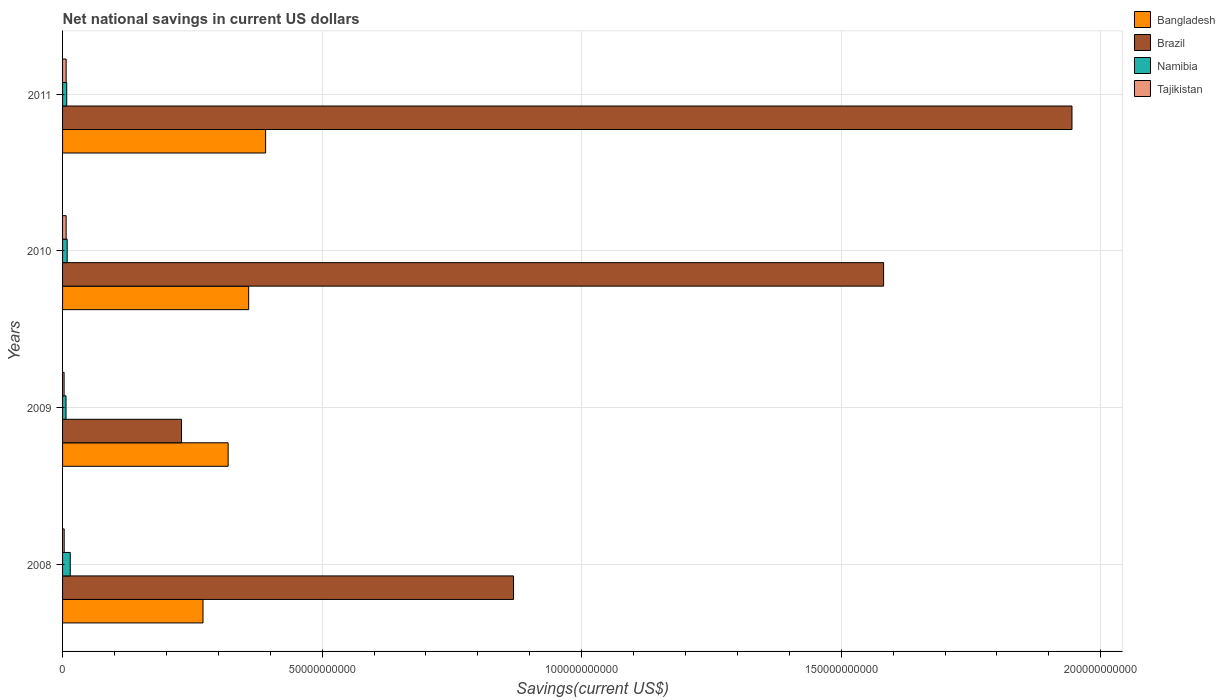How many different coloured bars are there?
Provide a short and direct response. 4. How many groups of bars are there?
Keep it short and to the point. 4. Are the number of bars per tick equal to the number of legend labels?
Give a very brief answer. Yes. How many bars are there on the 2nd tick from the bottom?
Give a very brief answer. 4. What is the label of the 2nd group of bars from the top?
Your response must be concise. 2010. In how many cases, is the number of bars for a given year not equal to the number of legend labels?
Offer a terse response. 0. What is the net national savings in Brazil in 2008?
Make the answer very short. 8.69e+1. Across all years, what is the maximum net national savings in Bangladesh?
Keep it short and to the point. 3.91e+1. Across all years, what is the minimum net national savings in Bangladesh?
Offer a very short reply. 2.71e+1. In which year was the net national savings in Bangladesh minimum?
Make the answer very short. 2008. What is the total net national savings in Tajikistan in the graph?
Provide a succinct answer. 1.98e+09. What is the difference between the net national savings in Tajikistan in 2010 and that in 2011?
Offer a terse response. -2.02e+06. What is the difference between the net national savings in Namibia in 2011 and the net national savings in Brazil in 2008?
Provide a short and direct response. -8.61e+1. What is the average net national savings in Brazil per year?
Provide a short and direct response. 1.16e+11. In the year 2011, what is the difference between the net national savings in Bangladesh and net national savings in Brazil?
Your answer should be very brief. -1.55e+11. What is the ratio of the net national savings in Namibia in 2008 to that in 2011?
Provide a short and direct response. 1.85. Is the difference between the net national savings in Bangladesh in 2009 and 2011 greater than the difference between the net national savings in Brazil in 2009 and 2011?
Make the answer very short. Yes. What is the difference between the highest and the second highest net national savings in Brazil?
Ensure brevity in your answer.  3.63e+1. What is the difference between the highest and the lowest net national savings in Namibia?
Provide a succinct answer. 8.15e+08. In how many years, is the net national savings in Tajikistan greater than the average net national savings in Tajikistan taken over all years?
Your answer should be very brief. 2. Is the sum of the net national savings in Tajikistan in 2008 and 2010 greater than the maximum net national savings in Namibia across all years?
Make the answer very short. No. Is it the case that in every year, the sum of the net national savings in Tajikistan and net national savings in Bangladesh is greater than the sum of net national savings in Brazil and net national savings in Namibia?
Offer a terse response. No. How many years are there in the graph?
Your answer should be compact. 4. What is the difference between two consecutive major ticks on the X-axis?
Your answer should be very brief. 5.00e+1. Are the values on the major ticks of X-axis written in scientific E-notation?
Your response must be concise. No. Does the graph contain any zero values?
Your answer should be compact. No. Where does the legend appear in the graph?
Ensure brevity in your answer.  Top right. What is the title of the graph?
Offer a terse response. Net national savings in current US dollars. What is the label or title of the X-axis?
Offer a terse response. Savings(current US$). What is the Savings(current US$) of Bangladesh in 2008?
Offer a terse response. 2.71e+1. What is the Savings(current US$) in Brazil in 2008?
Provide a succinct answer. 8.69e+1. What is the Savings(current US$) in Namibia in 2008?
Your answer should be compact. 1.48e+09. What is the Savings(current US$) of Tajikistan in 2008?
Keep it short and to the point. 3.11e+08. What is the Savings(current US$) of Bangladesh in 2009?
Your answer should be compact. 3.19e+1. What is the Savings(current US$) in Brazil in 2009?
Make the answer very short. 2.29e+1. What is the Savings(current US$) of Namibia in 2009?
Give a very brief answer. 6.64e+08. What is the Savings(current US$) of Tajikistan in 2009?
Your answer should be very brief. 2.95e+08. What is the Savings(current US$) in Bangladesh in 2010?
Give a very brief answer. 3.59e+1. What is the Savings(current US$) in Brazil in 2010?
Offer a terse response. 1.58e+11. What is the Savings(current US$) of Namibia in 2010?
Your answer should be compact. 8.89e+08. What is the Savings(current US$) in Tajikistan in 2010?
Provide a succinct answer. 6.86e+08. What is the Savings(current US$) of Bangladesh in 2011?
Provide a short and direct response. 3.91e+1. What is the Savings(current US$) of Brazil in 2011?
Offer a terse response. 1.94e+11. What is the Savings(current US$) of Namibia in 2011?
Make the answer very short. 8.00e+08. What is the Savings(current US$) of Tajikistan in 2011?
Give a very brief answer. 6.88e+08. Across all years, what is the maximum Savings(current US$) in Bangladesh?
Ensure brevity in your answer.  3.91e+1. Across all years, what is the maximum Savings(current US$) of Brazil?
Keep it short and to the point. 1.94e+11. Across all years, what is the maximum Savings(current US$) of Namibia?
Your answer should be very brief. 1.48e+09. Across all years, what is the maximum Savings(current US$) in Tajikistan?
Give a very brief answer. 6.88e+08. Across all years, what is the minimum Savings(current US$) in Bangladesh?
Provide a short and direct response. 2.71e+1. Across all years, what is the minimum Savings(current US$) of Brazil?
Keep it short and to the point. 2.29e+1. Across all years, what is the minimum Savings(current US$) of Namibia?
Give a very brief answer. 6.64e+08. Across all years, what is the minimum Savings(current US$) of Tajikistan?
Ensure brevity in your answer.  2.95e+08. What is the total Savings(current US$) of Bangladesh in the graph?
Give a very brief answer. 1.34e+11. What is the total Savings(current US$) of Brazil in the graph?
Make the answer very short. 4.62e+11. What is the total Savings(current US$) in Namibia in the graph?
Keep it short and to the point. 3.83e+09. What is the total Savings(current US$) of Tajikistan in the graph?
Your response must be concise. 1.98e+09. What is the difference between the Savings(current US$) in Bangladesh in 2008 and that in 2009?
Your answer should be very brief. -4.84e+09. What is the difference between the Savings(current US$) of Brazil in 2008 and that in 2009?
Provide a short and direct response. 6.40e+1. What is the difference between the Savings(current US$) of Namibia in 2008 and that in 2009?
Offer a very short reply. 8.15e+08. What is the difference between the Savings(current US$) of Tajikistan in 2008 and that in 2009?
Give a very brief answer. 1.60e+07. What is the difference between the Savings(current US$) in Bangladesh in 2008 and that in 2010?
Give a very brief answer. -8.80e+09. What is the difference between the Savings(current US$) in Brazil in 2008 and that in 2010?
Keep it short and to the point. -7.13e+1. What is the difference between the Savings(current US$) of Namibia in 2008 and that in 2010?
Offer a terse response. 5.90e+08. What is the difference between the Savings(current US$) of Tajikistan in 2008 and that in 2010?
Offer a terse response. -3.75e+08. What is the difference between the Savings(current US$) of Bangladesh in 2008 and that in 2011?
Your response must be concise. -1.21e+1. What is the difference between the Savings(current US$) of Brazil in 2008 and that in 2011?
Offer a very short reply. -1.08e+11. What is the difference between the Savings(current US$) of Namibia in 2008 and that in 2011?
Provide a succinct answer. 6.80e+08. What is the difference between the Savings(current US$) in Tajikistan in 2008 and that in 2011?
Offer a terse response. -3.77e+08. What is the difference between the Savings(current US$) of Bangladesh in 2009 and that in 2010?
Provide a short and direct response. -3.95e+09. What is the difference between the Savings(current US$) of Brazil in 2009 and that in 2010?
Ensure brevity in your answer.  -1.35e+11. What is the difference between the Savings(current US$) of Namibia in 2009 and that in 2010?
Your response must be concise. -2.25e+08. What is the difference between the Savings(current US$) of Tajikistan in 2009 and that in 2010?
Give a very brief answer. -3.91e+08. What is the difference between the Savings(current US$) of Bangladesh in 2009 and that in 2011?
Provide a succinct answer. -7.22e+09. What is the difference between the Savings(current US$) in Brazil in 2009 and that in 2011?
Make the answer very short. -1.72e+11. What is the difference between the Savings(current US$) in Namibia in 2009 and that in 2011?
Your answer should be very brief. -1.36e+08. What is the difference between the Savings(current US$) in Tajikistan in 2009 and that in 2011?
Your answer should be compact. -3.93e+08. What is the difference between the Savings(current US$) of Bangladesh in 2010 and that in 2011?
Your answer should be very brief. -3.26e+09. What is the difference between the Savings(current US$) of Brazil in 2010 and that in 2011?
Ensure brevity in your answer.  -3.63e+1. What is the difference between the Savings(current US$) in Namibia in 2010 and that in 2011?
Your answer should be very brief. 8.98e+07. What is the difference between the Savings(current US$) in Tajikistan in 2010 and that in 2011?
Ensure brevity in your answer.  -2.02e+06. What is the difference between the Savings(current US$) in Bangladesh in 2008 and the Savings(current US$) in Brazil in 2009?
Provide a short and direct response. 4.14e+09. What is the difference between the Savings(current US$) in Bangladesh in 2008 and the Savings(current US$) in Namibia in 2009?
Make the answer very short. 2.64e+1. What is the difference between the Savings(current US$) in Bangladesh in 2008 and the Savings(current US$) in Tajikistan in 2009?
Ensure brevity in your answer.  2.68e+1. What is the difference between the Savings(current US$) of Brazil in 2008 and the Savings(current US$) of Namibia in 2009?
Offer a terse response. 8.62e+1. What is the difference between the Savings(current US$) in Brazil in 2008 and the Savings(current US$) in Tajikistan in 2009?
Make the answer very short. 8.66e+1. What is the difference between the Savings(current US$) in Namibia in 2008 and the Savings(current US$) in Tajikistan in 2009?
Make the answer very short. 1.18e+09. What is the difference between the Savings(current US$) of Bangladesh in 2008 and the Savings(current US$) of Brazil in 2010?
Make the answer very short. -1.31e+11. What is the difference between the Savings(current US$) in Bangladesh in 2008 and the Savings(current US$) in Namibia in 2010?
Ensure brevity in your answer.  2.62e+1. What is the difference between the Savings(current US$) of Bangladesh in 2008 and the Savings(current US$) of Tajikistan in 2010?
Your response must be concise. 2.64e+1. What is the difference between the Savings(current US$) of Brazil in 2008 and the Savings(current US$) of Namibia in 2010?
Offer a very short reply. 8.60e+1. What is the difference between the Savings(current US$) in Brazil in 2008 and the Savings(current US$) in Tajikistan in 2010?
Provide a succinct answer. 8.62e+1. What is the difference between the Savings(current US$) of Namibia in 2008 and the Savings(current US$) of Tajikistan in 2010?
Make the answer very short. 7.93e+08. What is the difference between the Savings(current US$) in Bangladesh in 2008 and the Savings(current US$) in Brazil in 2011?
Your answer should be compact. -1.67e+11. What is the difference between the Savings(current US$) in Bangladesh in 2008 and the Savings(current US$) in Namibia in 2011?
Make the answer very short. 2.63e+1. What is the difference between the Savings(current US$) in Bangladesh in 2008 and the Savings(current US$) in Tajikistan in 2011?
Ensure brevity in your answer.  2.64e+1. What is the difference between the Savings(current US$) in Brazil in 2008 and the Savings(current US$) in Namibia in 2011?
Keep it short and to the point. 8.61e+1. What is the difference between the Savings(current US$) in Brazil in 2008 and the Savings(current US$) in Tajikistan in 2011?
Provide a short and direct response. 8.62e+1. What is the difference between the Savings(current US$) of Namibia in 2008 and the Savings(current US$) of Tajikistan in 2011?
Your response must be concise. 7.91e+08. What is the difference between the Savings(current US$) of Bangladesh in 2009 and the Savings(current US$) of Brazil in 2010?
Your answer should be very brief. -1.26e+11. What is the difference between the Savings(current US$) of Bangladesh in 2009 and the Savings(current US$) of Namibia in 2010?
Give a very brief answer. 3.10e+1. What is the difference between the Savings(current US$) in Bangladesh in 2009 and the Savings(current US$) in Tajikistan in 2010?
Offer a terse response. 3.12e+1. What is the difference between the Savings(current US$) in Brazil in 2009 and the Savings(current US$) in Namibia in 2010?
Your answer should be very brief. 2.20e+1. What is the difference between the Savings(current US$) of Brazil in 2009 and the Savings(current US$) of Tajikistan in 2010?
Make the answer very short. 2.22e+1. What is the difference between the Savings(current US$) of Namibia in 2009 and the Savings(current US$) of Tajikistan in 2010?
Ensure brevity in your answer.  -2.18e+07. What is the difference between the Savings(current US$) in Bangladesh in 2009 and the Savings(current US$) in Brazil in 2011?
Offer a very short reply. -1.63e+11. What is the difference between the Savings(current US$) of Bangladesh in 2009 and the Savings(current US$) of Namibia in 2011?
Keep it short and to the point. 3.11e+1. What is the difference between the Savings(current US$) of Bangladesh in 2009 and the Savings(current US$) of Tajikistan in 2011?
Provide a succinct answer. 3.12e+1. What is the difference between the Savings(current US$) of Brazil in 2009 and the Savings(current US$) of Namibia in 2011?
Ensure brevity in your answer.  2.21e+1. What is the difference between the Savings(current US$) in Brazil in 2009 and the Savings(current US$) in Tajikistan in 2011?
Offer a very short reply. 2.22e+1. What is the difference between the Savings(current US$) of Namibia in 2009 and the Savings(current US$) of Tajikistan in 2011?
Your response must be concise. -2.38e+07. What is the difference between the Savings(current US$) of Bangladesh in 2010 and the Savings(current US$) of Brazil in 2011?
Your answer should be compact. -1.59e+11. What is the difference between the Savings(current US$) of Bangladesh in 2010 and the Savings(current US$) of Namibia in 2011?
Your answer should be compact. 3.51e+1. What is the difference between the Savings(current US$) of Bangladesh in 2010 and the Savings(current US$) of Tajikistan in 2011?
Offer a very short reply. 3.52e+1. What is the difference between the Savings(current US$) in Brazil in 2010 and the Savings(current US$) in Namibia in 2011?
Your answer should be very brief. 1.57e+11. What is the difference between the Savings(current US$) of Brazil in 2010 and the Savings(current US$) of Tajikistan in 2011?
Your answer should be very brief. 1.57e+11. What is the difference between the Savings(current US$) in Namibia in 2010 and the Savings(current US$) in Tajikistan in 2011?
Ensure brevity in your answer.  2.02e+08. What is the average Savings(current US$) in Bangladesh per year?
Provide a short and direct response. 3.35e+1. What is the average Savings(current US$) in Brazil per year?
Give a very brief answer. 1.16e+11. What is the average Savings(current US$) of Namibia per year?
Offer a terse response. 9.58e+08. What is the average Savings(current US$) in Tajikistan per year?
Keep it short and to the point. 4.95e+08. In the year 2008, what is the difference between the Savings(current US$) of Bangladesh and Savings(current US$) of Brazil?
Your response must be concise. -5.98e+1. In the year 2008, what is the difference between the Savings(current US$) in Bangladesh and Savings(current US$) in Namibia?
Provide a succinct answer. 2.56e+1. In the year 2008, what is the difference between the Savings(current US$) of Bangladesh and Savings(current US$) of Tajikistan?
Your answer should be compact. 2.67e+1. In the year 2008, what is the difference between the Savings(current US$) of Brazil and Savings(current US$) of Namibia?
Provide a succinct answer. 8.54e+1. In the year 2008, what is the difference between the Savings(current US$) in Brazil and Savings(current US$) in Tajikistan?
Offer a very short reply. 8.66e+1. In the year 2008, what is the difference between the Savings(current US$) of Namibia and Savings(current US$) of Tajikistan?
Ensure brevity in your answer.  1.17e+09. In the year 2009, what is the difference between the Savings(current US$) of Bangladesh and Savings(current US$) of Brazil?
Keep it short and to the point. 8.98e+09. In the year 2009, what is the difference between the Savings(current US$) of Bangladesh and Savings(current US$) of Namibia?
Your response must be concise. 3.12e+1. In the year 2009, what is the difference between the Savings(current US$) of Bangladesh and Savings(current US$) of Tajikistan?
Keep it short and to the point. 3.16e+1. In the year 2009, what is the difference between the Savings(current US$) in Brazil and Savings(current US$) in Namibia?
Your answer should be very brief. 2.22e+1. In the year 2009, what is the difference between the Savings(current US$) of Brazil and Savings(current US$) of Tajikistan?
Your answer should be compact. 2.26e+1. In the year 2009, what is the difference between the Savings(current US$) in Namibia and Savings(current US$) in Tajikistan?
Keep it short and to the point. 3.69e+08. In the year 2010, what is the difference between the Savings(current US$) of Bangladesh and Savings(current US$) of Brazil?
Offer a terse response. -1.22e+11. In the year 2010, what is the difference between the Savings(current US$) in Bangladesh and Savings(current US$) in Namibia?
Offer a terse response. 3.50e+1. In the year 2010, what is the difference between the Savings(current US$) in Bangladesh and Savings(current US$) in Tajikistan?
Your response must be concise. 3.52e+1. In the year 2010, what is the difference between the Savings(current US$) of Brazil and Savings(current US$) of Namibia?
Provide a short and direct response. 1.57e+11. In the year 2010, what is the difference between the Savings(current US$) in Brazil and Savings(current US$) in Tajikistan?
Ensure brevity in your answer.  1.57e+11. In the year 2010, what is the difference between the Savings(current US$) of Namibia and Savings(current US$) of Tajikistan?
Provide a short and direct response. 2.04e+08. In the year 2011, what is the difference between the Savings(current US$) in Bangladesh and Savings(current US$) in Brazil?
Offer a terse response. -1.55e+11. In the year 2011, what is the difference between the Savings(current US$) in Bangladesh and Savings(current US$) in Namibia?
Give a very brief answer. 3.83e+1. In the year 2011, what is the difference between the Savings(current US$) of Bangladesh and Savings(current US$) of Tajikistan?
Offer a terse response. 3.84e+1. In the year 2011, what is the difference between the Savings(current US$) of Brazil and Savings(current US$) of Namibia?
Your answer should be compact. 1.94e+11. In the year 2011, what is the difference between the Savings(current US$) in Brazil and Savings(current US$) in Tajikistan?
Your response must be concise. 1.94e+11. In the year 2011, what is the difference between the Savings(current US$) in Namibia and Savings(current US$) in Tajikistan?
Provide a short and direct response. 1.12e+08. What is the ratio of the Savings(current US$) in Bangladesh in 2008 to that in 2009?
Your answer should be compact. 0.85. What is the ratio of the Savings(current US$) of Brazil in 2008 to that in 2009?
Ensure brevity in your answer.  3.79. What is the ratio of the Savings(current US$) of Namibia in 2008 to that in 2009?
Offer a very short reply. 2.23. What is the ratio of the Savings(current US$) in Tajikistan in 2008 to that in 2009?
Keep it short and to the point. 1.05. What is the ratio of the Savings(current US$) of Bangladesh in 2008 to that in 2010?
Your answer should be very brief. 0.75. What is the ratio of the Savings(current US$) of Brazil in 2008 to that in 2010?
Keep it short and to the point. 0.55. What is the ratio of the Savings(current US$) of Namibia in 2008 to that in 2010?
Provide a succinct answer. 1.66. What is the ratio of the Savings(current US$) in Tajikistan in 2008 to that in 2010?
Offer a very short reply. 0.45. What is the ratio of the Savings(current US$) of Bangladesh in 2008 to that in 2011?
Offer a terse response. 0.69. What is the ratio of the Savings(current US$) of Brazil in 2008 to that in 2011?
Ensure brevity in your answer.  0.45. What is the ratio of the Savings(current US$) of Namibia in 2008 to that in 2011?
Provide a short and direct response. 1.85. What is the ratio of the Savings(current US$) in Tajikistan in 2008 to that in 2011?
Your answer should be very brief. 0.45. What is the ratio of the Savings(current US$) of Bangladesh in 2009 to that in 2010?
Make the answer very short. 0.89. What is the ratio of the Savings(current US$) in Brazil in 2009 to that in 2010?
Offer a terse response. 0.14. What is the ratio of the Savings(current US$) of Namibia in 2009 to that in 2010?
Your answer should be very brief. 0.75. What is the ratio of the Savings(current US$) in Tajikistan in 2009 to that in 2010?
Give a very brief answer. 0.43. What is the ratio of the Savings(current US$) of Bangladesh in 2009 to that in 2011?
Your answer should be compact. 0.82. What is the ratio of the Savings(current US$) of Brazil in 2009 to that in 2011?
Give a very brief answer. 0.12. What is the ratio of the Savings(current US$) in Namibia in 2009 to that in 2011?
Provide a succinct answer. 0.83. What is the ratio of the Savings(current US$) of Tajikistan in 2009 to that in 2011?
Provide a succinct answer. 0.43. What is the ratio of the Savings(current US$) of Bangladesh in 2010 to that in 2011?
Give a very brief answer. 0.92. What is the ratio of the Savings(current US$) in Brazil in 2010 to that in 2011?
Your answer should be compact. 0.81. What is the ratio of the Savings(current US$) of Namibia in 2010 to that in 2011?
Keep it short and to the point. 1.11. What is the difference between the highest and the second highest Savings(current US$) of Bangladesh?
Ensure brevity in your answer.  3.26e+09. What is the difference between the highest and the second highest Savings(current US$) in Brazil?
Make the answer very short. 3.63e+1. What is the difference between the highest and the second highest Savings(current US$) in Namibia?
Keep it short and to the point. 5.90e+08. What is the difference between the highest and the second highest Savings(current US$) of Tajikistan?
Offer a terse response. 2.02e+06. What is the difference between the highest and the lowest Savings(current US$) in Bangladesh?
Provide a succinct answer. 1.21e+1. What is the difference between the highest and the lowest Savings(current US$) in Brazil?
Provide a succinct answer. 1.72e+11. What is the difference between the highest and the lowest Savings(current US$) in Namibia?
Ensure brevity in your answer.  8.15e+08. What is the difference between the highest and the lowest Savings(current US$) of Tajikistan?
Offer a very short reply. 3.93e+08. 